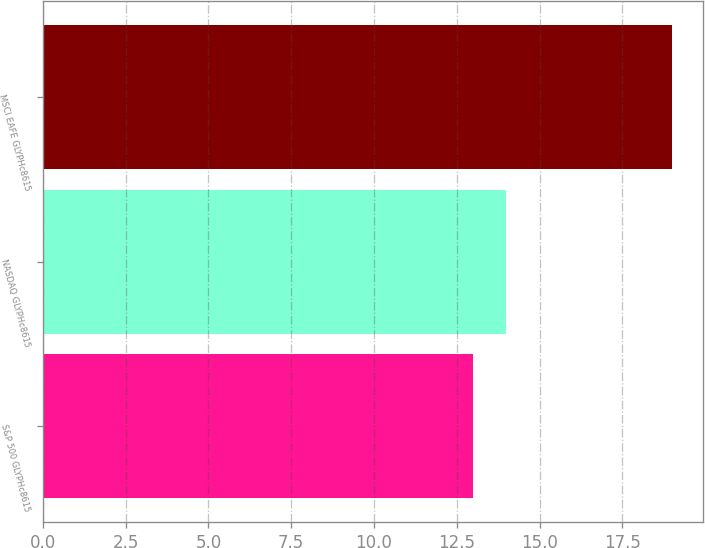Convert chart. <chart><loc_0><loc_0><loc_500><loc_500><bar_chart><fcel>S&P 500 GLYPHc8615<fcel>NASDAQ GLYPHc8615<fcel>MSCI EAFE GLYPHc8615<nl><fcel>13<fcel>14<fcel>19<nl></chart> 